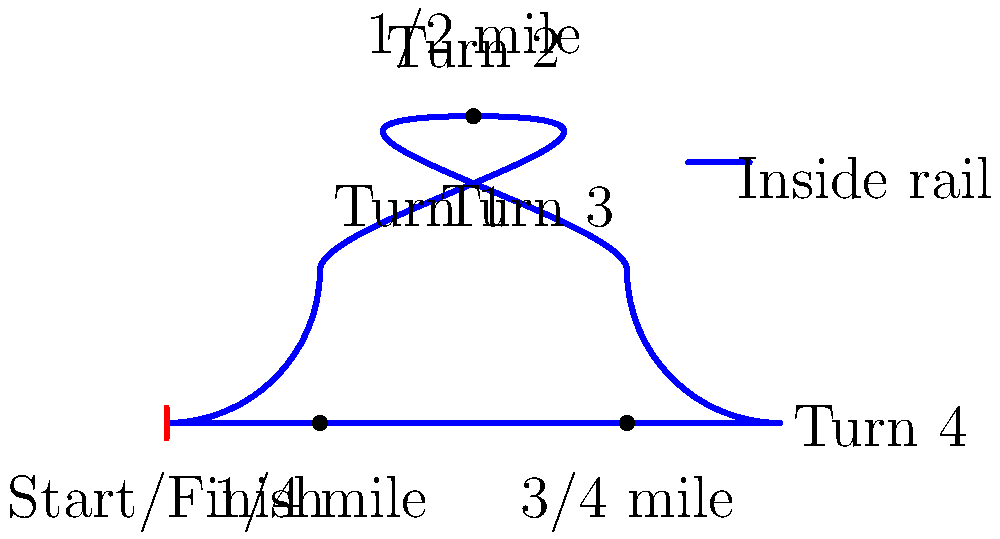Based on the track layout shown, which turn is likely to be the most critical for maintaining optimal speed and position in a one-mile race? Explain your reasoning considering the track's shape and the positioning of the turns. To determine the most critical turn for maintaining optimal speed and position, we need to analyze the track layout:

1. The track is a one-mile oval with four turns.
2. Turn 1 occurs at the 1/4 mile mark.
3. Turn 2 is at the 1/2 mile mark, at the far end of the track.
4. Turn 3 is at the 3/4 mile mark.
5. Turn 4 leads into the final stretch.

Analyzing each turn:
1. Turn 1: Occurs early in the race when horses are still jockeying for position.
2. Turn 2: Positioned at the halfway point, where horses have settled into their racing positions.
3. Turn 3: Comes after the backstretch, where horses may have made moves to improve position.
4. Turn 4: Leads into the final stretch, crucial for setting up the finish.

Turn 4 is likely the most critical for several reasons:
1. It's the last turn before the finish line, making it crucial for positioning.
2. Horses are typically at their maximum effort at this point in the race.
3. A good exit from Turn 4 can set up a strong finish down the final stretch.
4. Maintaining speed through this turn can prevent competitors from overtaking in the final stretch.
5. Any ground lost here is difficult to make up in the short distance to the finish line.

While all turns are important, Turn 4's position just before the finish line makes it the most critical for maintaining optimal speed and position to win the race.
Answer: Turn 4 